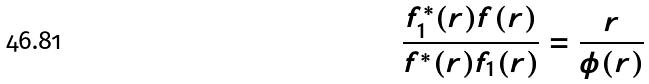Convert formula to latex. <formula><loc_0><loc_0><loc_500><loc_500>\frac { f _ { 1 } ^ { * } ( r ) f ( r ) } { f ^ { * } ( r ) f _ { 1 } ( r ) } = \frac { r } { \phi ( r ) }</formula> 